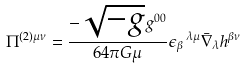Convert formula to latex. <formula><loc_0><loc_0><loc_500><loc_500>\Pi ^ { ( 2 ) \mu \nu } = \frac { - \sqrt { - g } g ^ { 0 0 } } { 6 4 \pi G \mu } \epsilon _ { \beta } \, ^ { \lambda \mu } \bar { \nabla } _ { \lambda } h ^ { \beta \nu }</formula> 